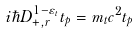<formula> <loc_0><loc_0><loc_500><loc_500>i \hbar { D } _ { + , { r } } ^ { 1 - \varepsilon _ { t } } t _ { p } = m _ { t } c ^ { 2 } t _ { p }</formula> 